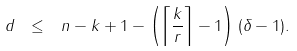<formula> <loc_0><loc_0><loc_500><loc_500>d \ \leq \ n - k + 1 - \left ( \left \lceil { \frac { k } { r } } \right \rceil - 1 \right ) ( \delta - 1 ) .</formula> 